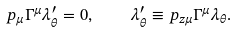Convert formula to latex. <formula><loc_0><loc_0><loc_500><loc_500>p _ { \mu } \Gamma ^ { \mu } \lambda _ { \theta } ^ { \prime } = 0 , \quad \lambda _ { \theta } ^ { \prime } \equiv p _ { z \mu } \Gamma ^ { \mu } \lambda _ { \theta } .</formula> 